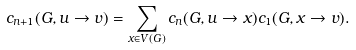<formula> <loc_0><loc_0><loc_500><loc_500>c _ { n + 1 } ( G , u \rightarrow v ) = \sum _ { x \in V ( G ) } c _ { n } ( G , u \rightarrow x ) c _ { 1 } ( G , x \rightarrow v ) .</formula> 